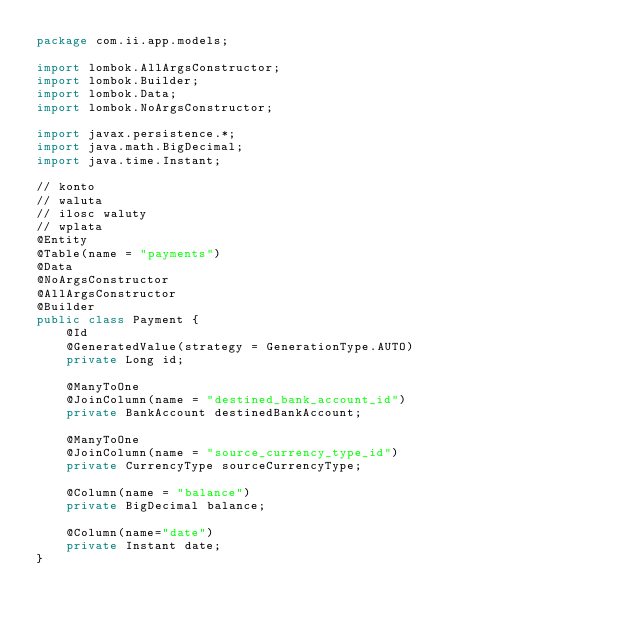Convert code to text. <code><loc_0><loc_0><loc_500><loc_500><_Java_>package com.ii.app.models;

import lombok.AllArgsConstructor;
import lombok.Builder;
import lombok.Data;
import lombok.NoArgsConstructor;

import javax.persistence.*;
import java.math.BigDecimal;
import java.time.Instant;

// konto
// waluta
// ilosc waluty
// wplata
@Entity
@Table(name = "payments")
@Data
@NoArgsConstructor
@AllArgsConstructor
@Builder
public class Payment {
    @Id
    @GeneratedValue(strategy = GenerationType.AUTO)
    private Long id;

    @ManyToOne
    @JoinColumn(name = "destined_bank_account_id")
    private BankAccount destinedBankAccount;

    @ManyToOne
    @JoinColumn(name = "source_currency_type_id")
    private CurrencyType sourceCurrencyType;

    @Column(name = "balance")
    private BigDecimal balance;

    @Column(name="date")
    private Instant date;
}
</code> 